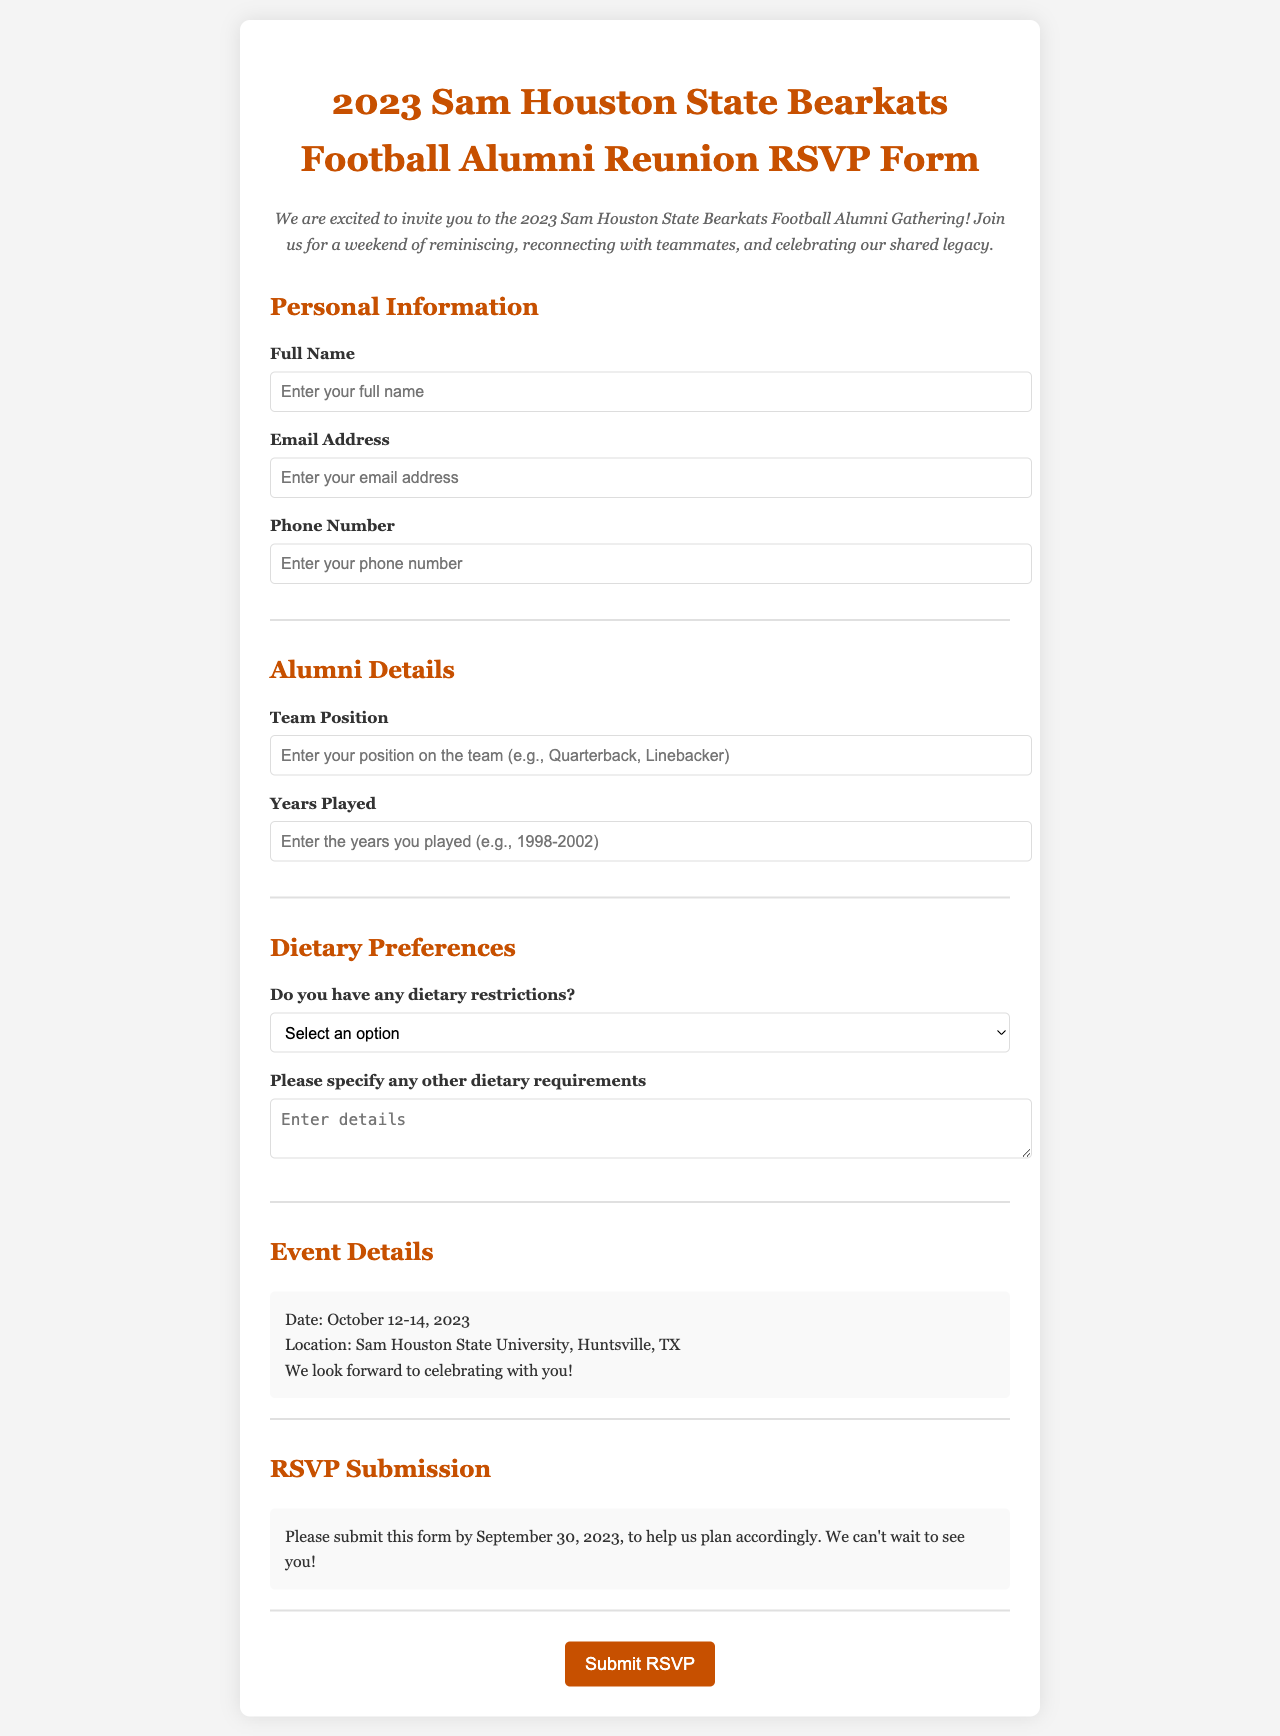what is the title of the document? The title is specified in the head section of the HTML and gives the purpose of the form.
Answer: 2023 Sam Houston State Bearkats Football Alumni Reunion RSVP Form what is the deadline for submitting the RSVP? The deadline for submission is explicitly stated in the RSVP section of the document.
Answer: September 30, 2023 what is the location of the reunion event? The location is mentioned in the event details section, providing clear information for attendees.
Answer: Sam Houston State University, Huntsville, TX which dietary option is not available in the selection? The options listed in the dietary preferences section provide choices, one of which is absent.
Answer: Meat-based options what year did the person likely play on the team if they indicate they played for four years and have to submit the RSVP by 2023? By reasoning from the years played and the current year, we can determine the starting year of their participation.
Answer: 1998 who is the targeted audience for this form? The introduction summarizes the purpose and identifies the group being invited.
Answer: Alumni of the Sam Houston State Bearkats football team what is the style of the font used in the document? The style is indicated in the CSS section under the body rules.
Answer: Georgia how can the user specify their other dietary requirements? The form provides a specific field for additional information regarding dietary preferences.
Answer: Using the textarea provided 